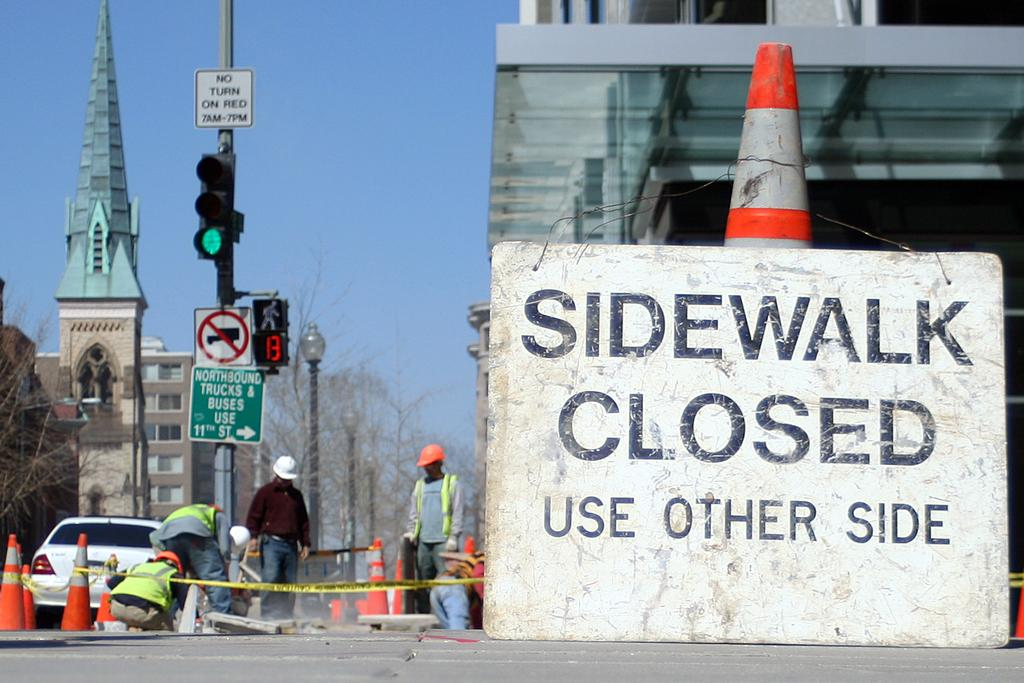<image>
Render a clear and concise summary of the photo. A sidewalk is closed due to construction underway on the path. 